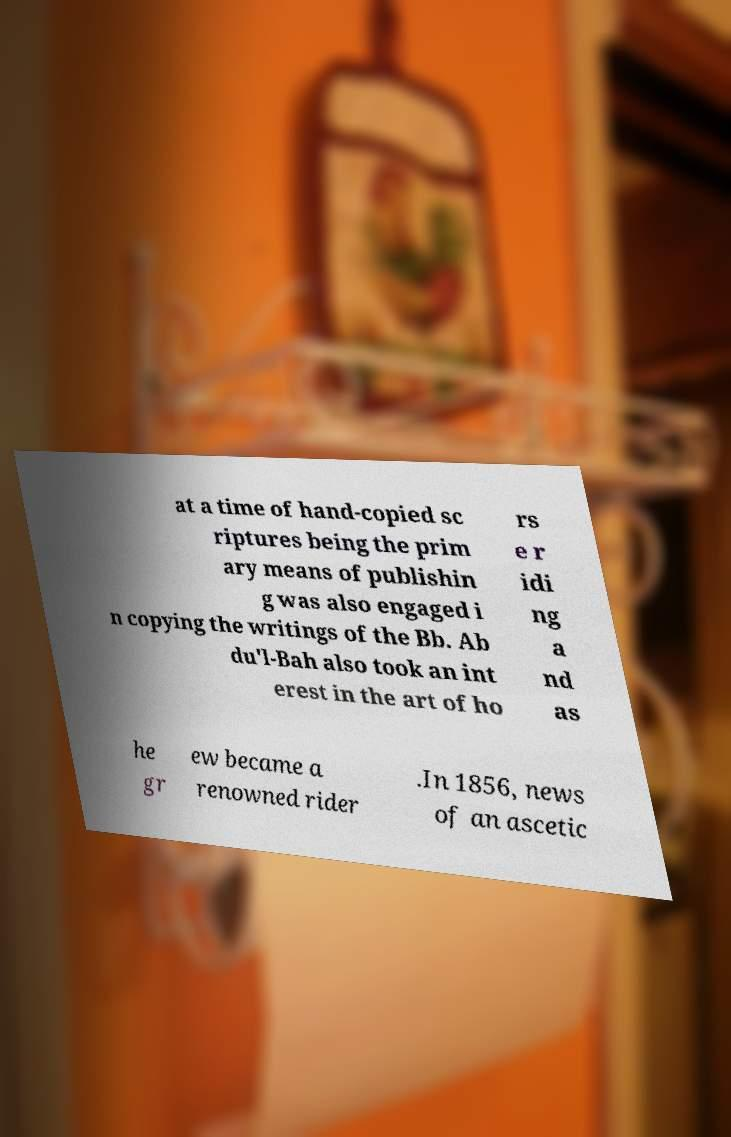Can you read and provide the text displayed in the image?This photo seems to have some interesting text. Can you extract and type it out for me? at a time of hand-copied sc riptures being the prim ary means of publishin g was also engaged i n copying the writings of the Bb. Ab du'l-Bah also took an int erest in the art of ho rs e r idi ng a nd as he gr ew became a renowned rider .In 1856, news of an ascetic 